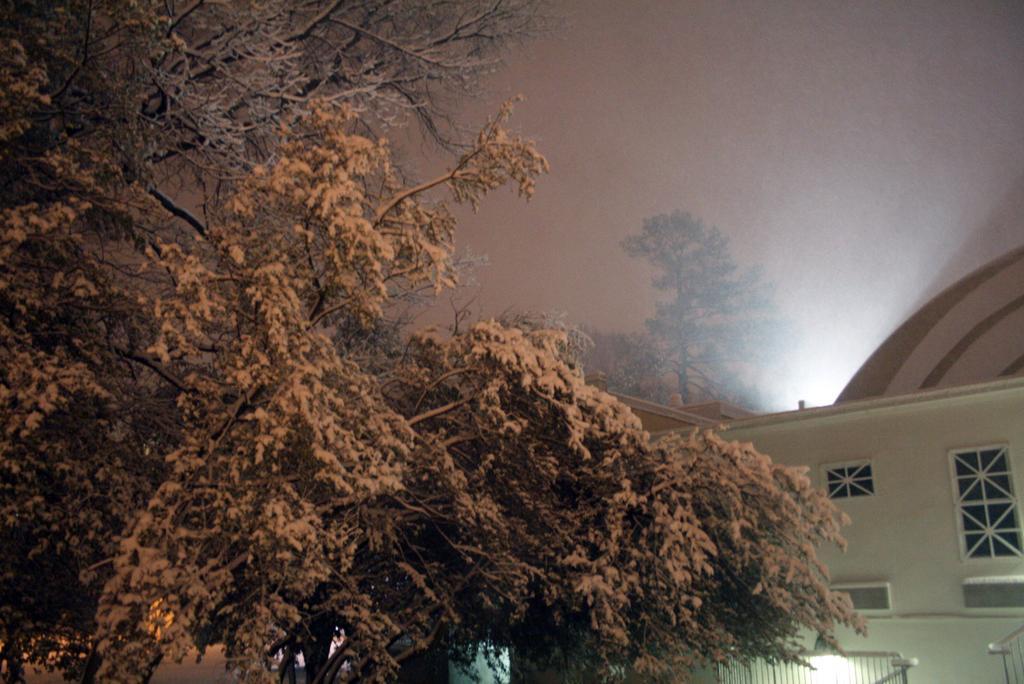Please provide a concise description of this image. In this picture we can see trees,building and we can see sky in the background. 